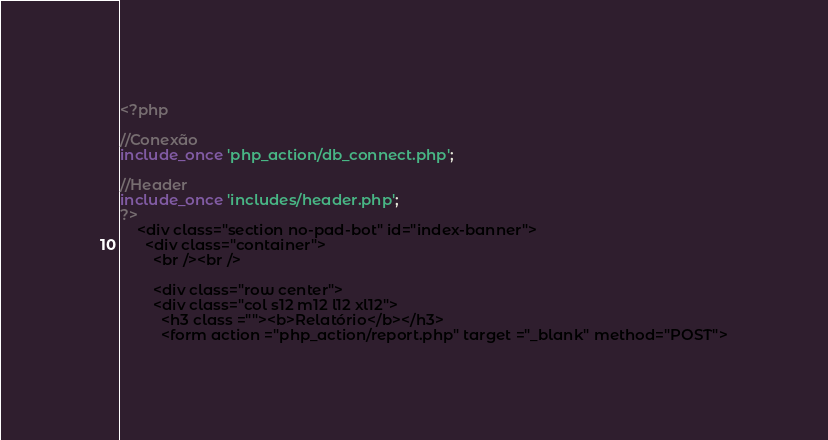<code> <loc_0><loc_0><loc_500><loc_500><_PHP_><?php

//Conexão
include_once 'php_action/db_connect.php';

//Header
include_once 'includes/header.php';
?>
    <div class="section no-pad-bot" id="index-banner">
      <div class="container">
        <br /><br />

        <div class="row center">
        <div class="col s12 m12 l12 xl12">
          <h3 class =""><b>Relatório</b></h3>
          <form action ="php_action/report.php" target ="_blank" method="POST"></code> 